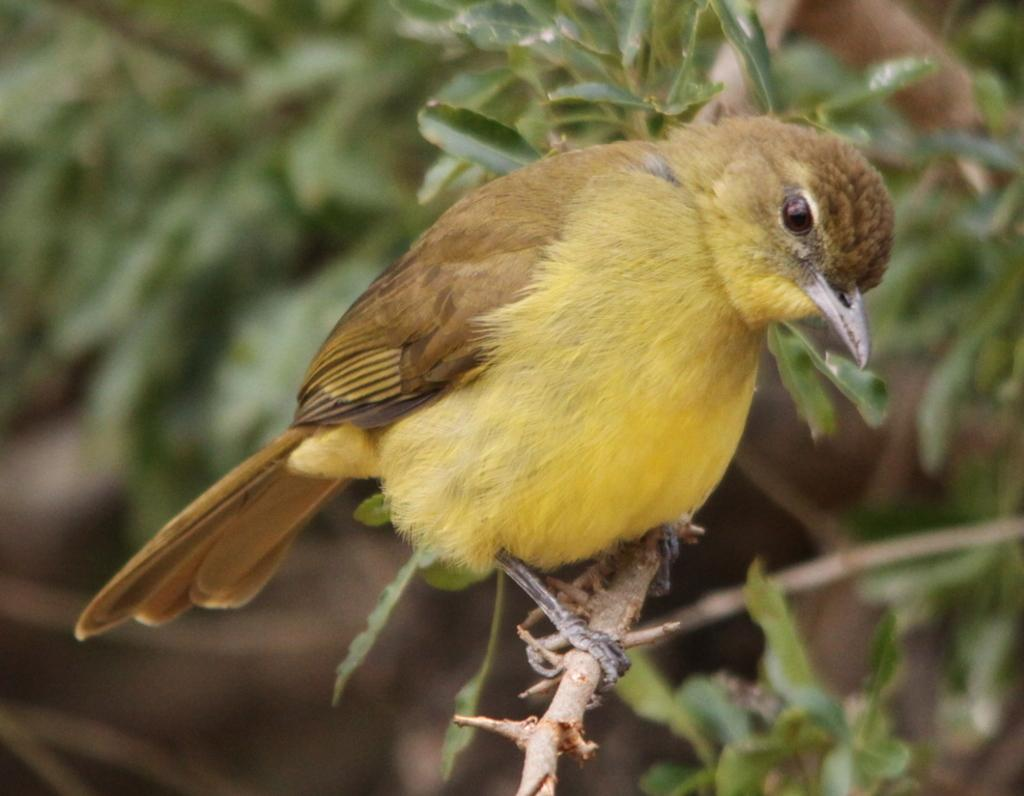What type of animal can be seen in the image? There is a bird in the image. Where is the bird located in the image? The bird is sitting on a branch. What colors can be observed on the bird? The bird has yellow, brown, and black colors. What type of vegetation is present in the image? There are green leaves in the image. What type of range does the bird use to cook its meals in the image? There is no range present in the image, as it features a bird sitting on a branch. How does the bird sort the leaves in the image? The bird does not sort the leaves in the image; it is simply sitting on a branch. 